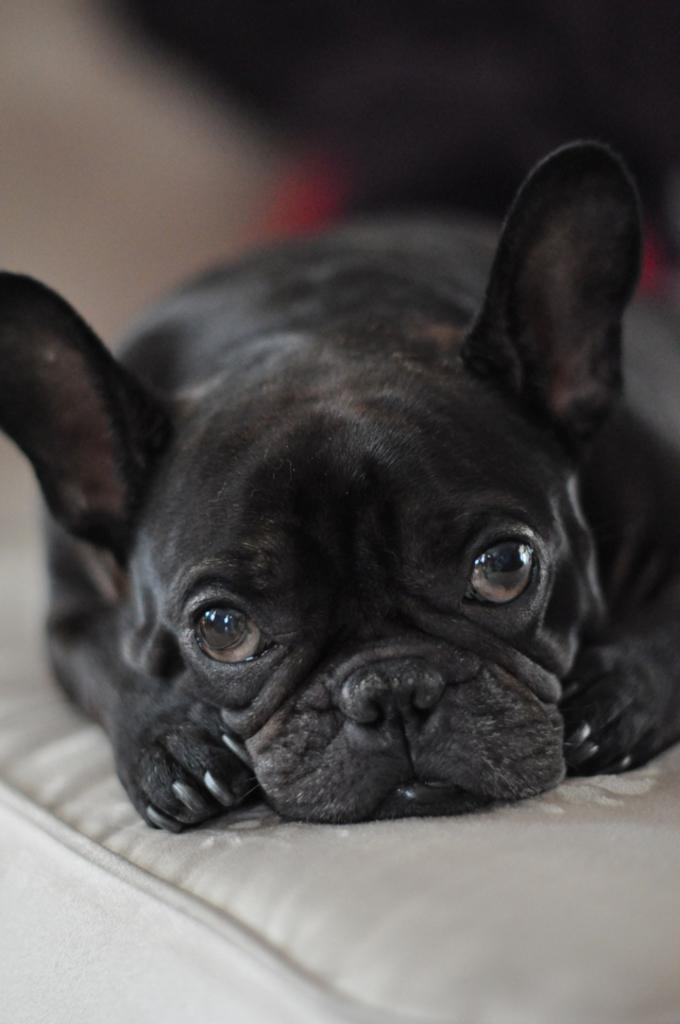What type of animal is in the image? There is a black dog in the image. What is the dog standing or sitting on? The dog is on a surface. Can you describe the background of the image? The background of the image is blurry. What type of paper is the dog holding for its birthday celebration in the image? There is no paper or birthday celebration present in the image; it features a black dog on a surface with a blurry background. 